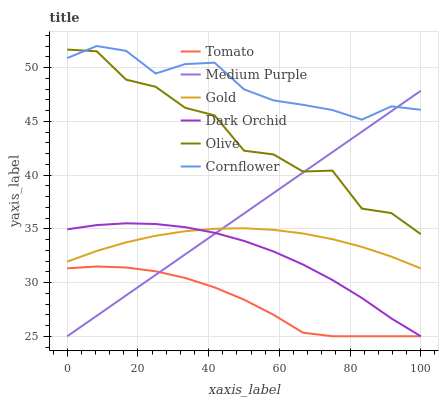Does Tomato have the minimum area under the curve?
Answer yes or no. Yes. Does Cornflower have the maximum area under the curve?
Answer yes or no. Yes. Does Gold have the minimum area under the curve?
Answer yes or no. No. Does Gold have the maximum area under the curve?
Answer yes or no. No. Is Medium Purple the smoothest?
Answer yes or no. Yes. Is Olive the roughest?
Answer yes or no. Yes. Is Cornflower the smoothest?
Answer yes or no. No. Is Cornflower the roughest?
Answer yes or no. No. Does Tomato have the lowest value?
Answer yes or no. Yes. Does Gold have the lowest value?
Answer yes or no. No. Does Cornflower have the highest value?
Answer yes or no. Yes. Does Gold have the highest value?
Answer yes or no. No. Is Dark Orchid less than Olive?
Answer yes or no. Yes. Is Olive greater than Dark Orchid?
Answer yes or no. Yes. Does Medium Purple intersect Olive?
Answer yes or no. Yes. Is Medium Purple less than Olive?
Answer yes or no. No. Is Medium Purple greater than Olive?
Answer yes or no. No. Does Dark Orchid intersect Olive?
Answer yes or no. No. 